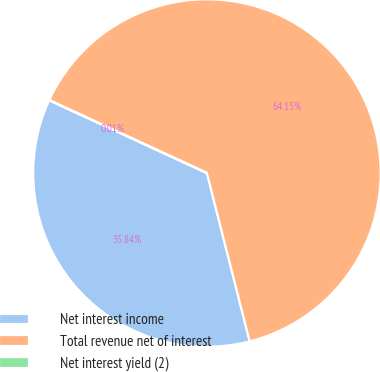Convert chart. <chart><loc_0><loc_0><loc_500><loc_500><pie_chart><fcel>Net interest income<fcel>Total revenue net of interest<fcel>Net interest yield (2)<nl><fcel>35.84%<fcel>64.15%<fcel>0.01%<nl></chart> 